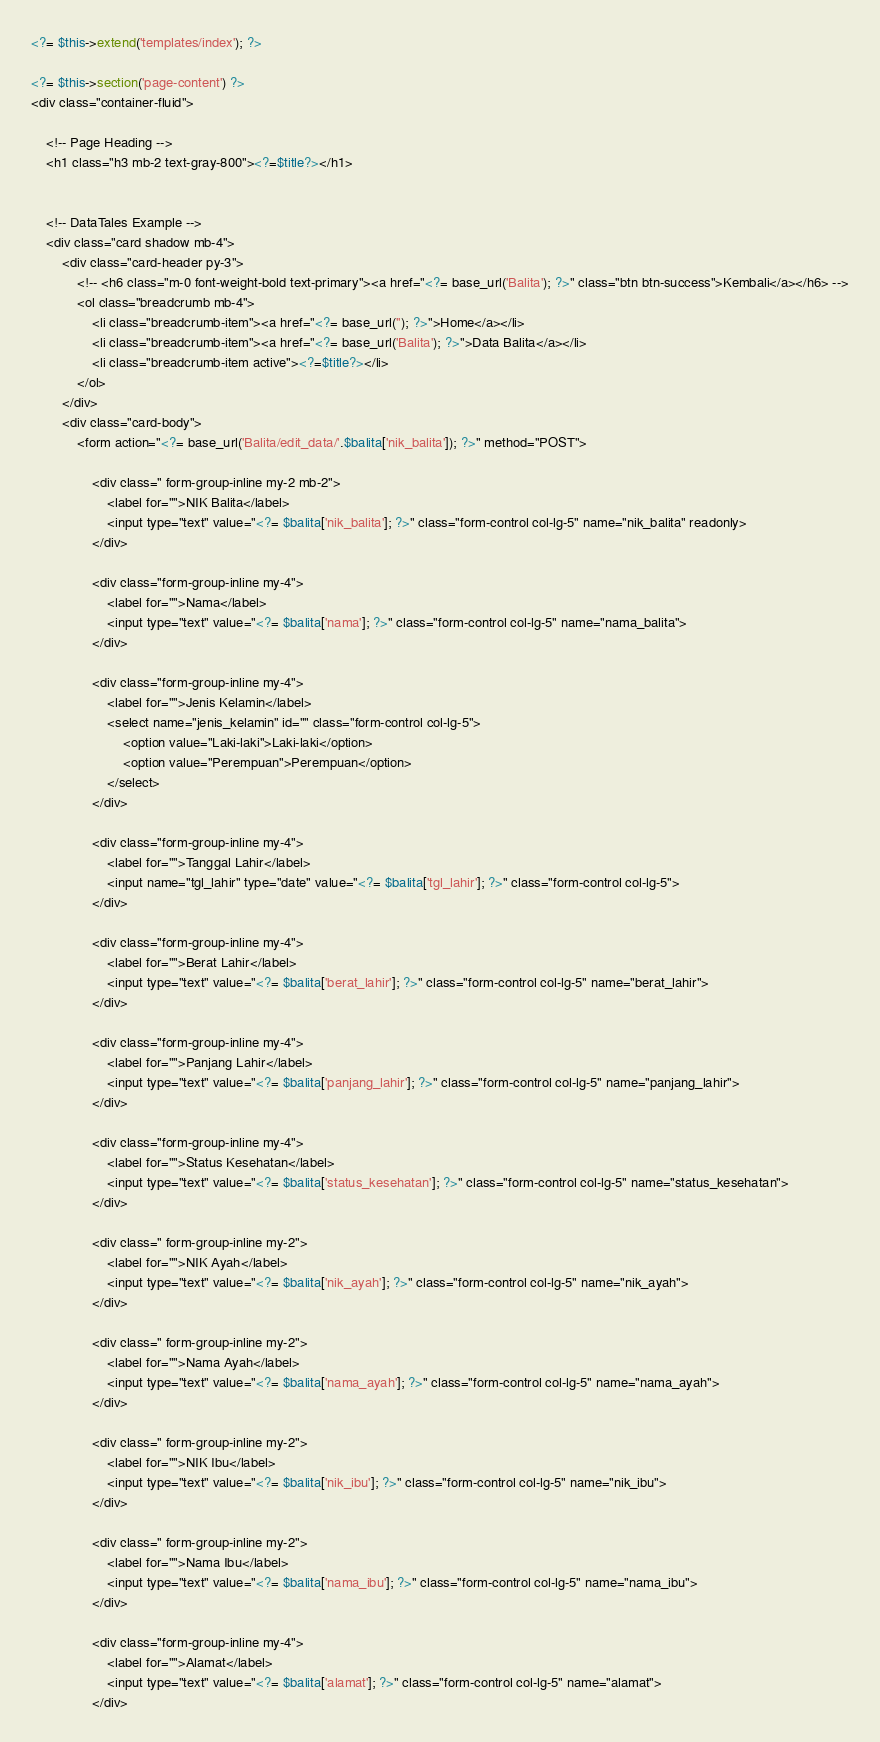<code> <loc_0><loc_0><loc_500><loc_500><_PHP_><?= $this->extend('templates/index'); ?>     
         
<?= $this->section('page-content') ?>
<div class="container-fluid">

    <!-- Page Heading -->
    <h1 class="h3 mb-2 text-gray-800"><?=$title?></h1>
    

    <!-- DataTales Example -->
    <div class="card shadow mb-4">
        <div class="card-header py-3">
            <!-- <h6 class="m-0 font-weight-bold text-primary"><a href="<?= base_url('Balita'); ?>" class="btn btn-success">Kembali</a></h6> -->
            <ol class="breadcrumb mb-4">
                <li class="breadcrumb-item"><a href="<?= base_url(''); ?>">Home</a></li>
                <li class="breadcrumb-item"><a href="<?= base_url('Balita'); ?>">Data Balita</a></li>
                <li class="breadcrumb-item active"><?=$title?></li>
            </ol>
        </div>
        <div class="card-body">
            <form action="<?= base_url('Balita/edit_data/'.$balita['nik_balita']); ?>" method="POST">
            
                <div class=" form-group-inline my-2 mb-2">
                    <label for="">NIK Balita</label>
                    <input type="text" value="<?= $balita['nik_balita']; ?>" class="form-control col-lg-5" name="nik_balita" readonly>
                </div>

                <div class="form-group-inline my-4">
                    <label for="">Nama</label>
                    <input type="text" value="<?= $balita['nama']; ?>" class="form-control col-lg-5" name="nama_balita">
                </div>

                <div class="form-group-inline my-4">
                    <label for="">Jenis Kelamin</label>
                    <select name="jenis_kelamin" id="" class="form-control col-lg-5">
                        <option value="Laki-laki">Laki-laki</option>
                        <option value="Perempuan">Perempuan</option>
                    </select>
                </div>

                <div class="form-group-inline my-4">
                    <label for="">Tanggal Lahir</label>
                    <input name="tgl_lahir" type="date" value="<?= $balita['tgl_lahir']; ?>" class="form-control col-lg-5">
                </div>

                <div class="form-group-inline my-4">
                    <label for="">Berat Lahir</label>
                    <input type="text" value="<?= $balita['berat_lahir']; ?>" class="form-control col-lg-5" name="berat_lahir">
                </div>

                <div class="form-group-inline my-4">
                    <label for="">Panjang Lahir</label>
                    <input type="text" value="<?= $balita['panjang_lahir']; ?>" class="form-control col-lg-5" name="panjang_lahir">
                </div>
               
                <div class="form-group-inline my-4">
                    <label for="">Status Kesehatan</label>
                    <input type="text" value="<?= $balita['status_kesehatan']; ?>" class="form-control col-lg-5" name="status_kesehatan">
                </div>

                <div class=" form-group-inline my-2">
                    <label for="">NIK Ayah</label>
                    <input type="text" value="<?= $balita['nik_ayah']; ?>" class="form-control col-lg-5" name="nik_ayah">
                </div>

                <div class=" form-group-inline my-2">
                    <label for="">Nama Ayah</label>
                    <input type="text" value="<?= $balita['nama_ayah']; ?>" class="form-control col-lg-5" name="nama_ayah">
                </div>

                <div class=" form-group-inline my-2">
                    <label for="">NIK Ibu</label>
                    <input type="text" value="<?= $balita['nik_ibu']; ?>" class="form-control col-lg-5" name="nik_ibu">
                </div>

                <div class=" form-group-inline my-2">
                    <label for="">Nama Ibu</label>
                    <input type="text" value="<?= $balita['nama_ibu']; ?>" class="form-control col-lg-5" name="nama_ibu">
                </div>

                <div class="form-group-inline my-4">
                    <label for="">Alamat</label>
                    <input type="text" value="<?= $balita['alamat']; ?>" class="form-control col-lg-5" name="alamat">
                </div>
</code> 